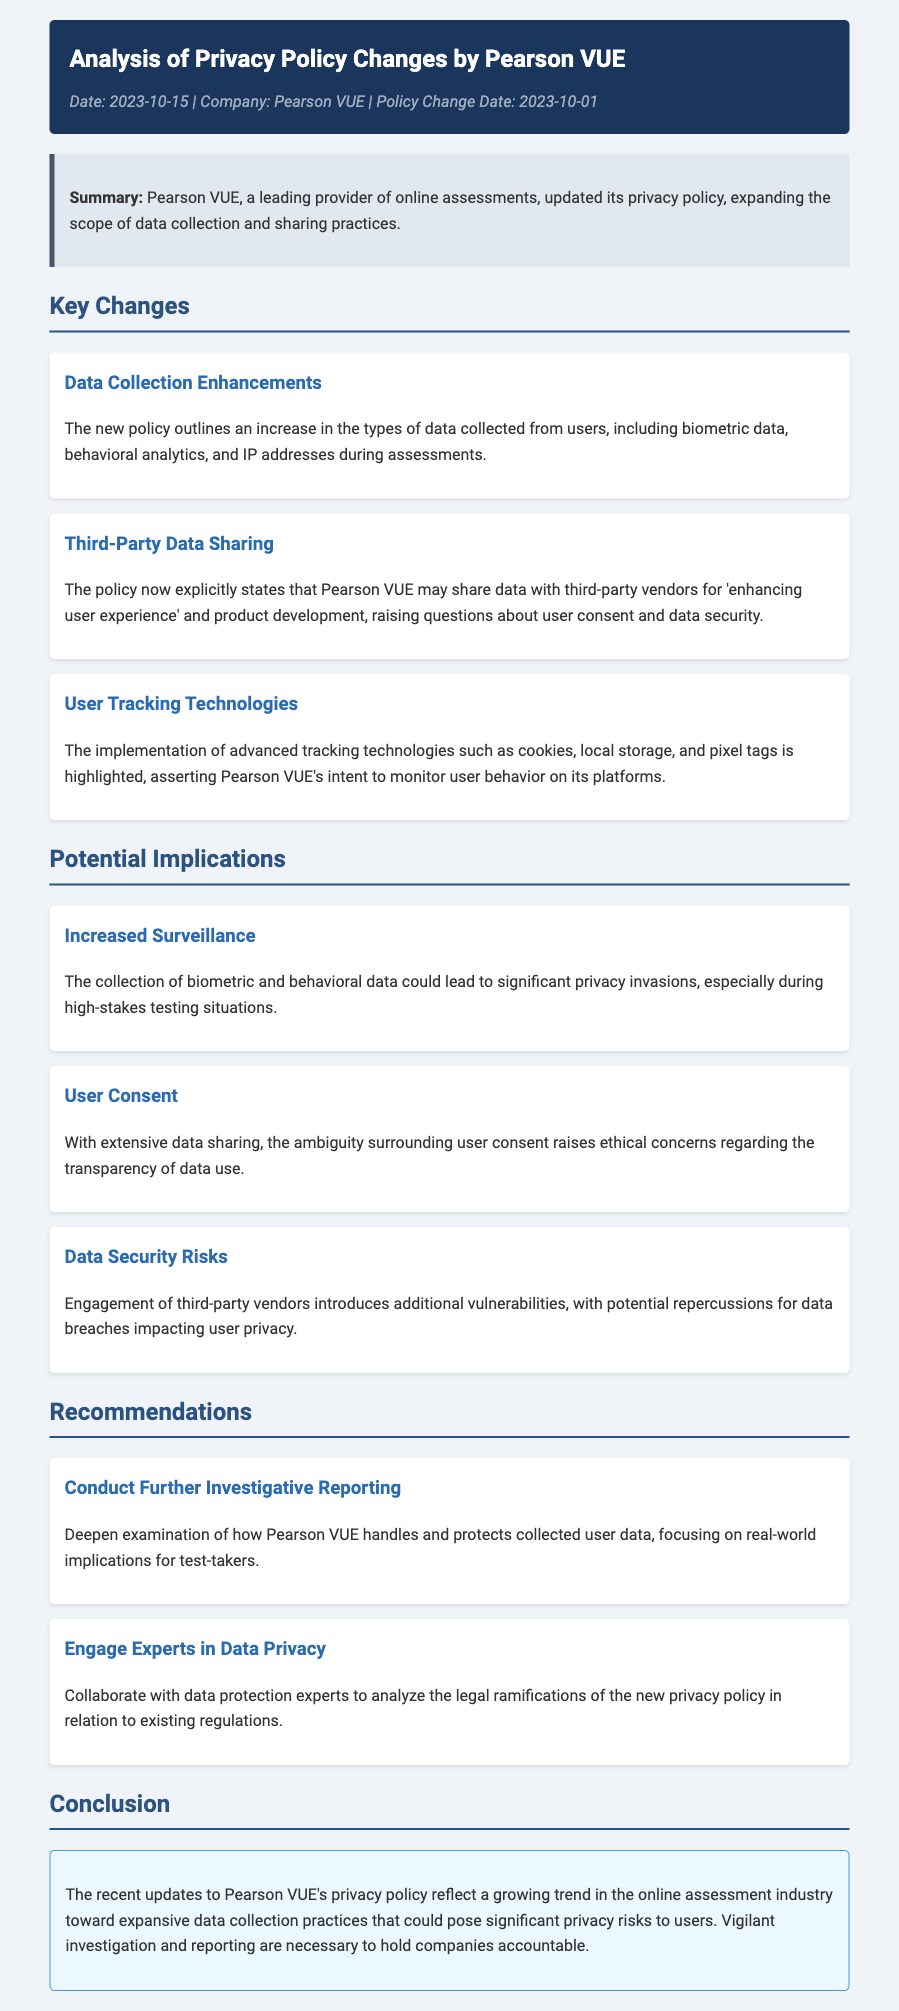What is the date of the privacy policy change? The privacy policy change took effect on 2023-10-01, as stated in the document.
Answer: 2023-10-01 What type of data collection has increased according to the new policy? The new policy mentions an increase in biometric data, behavioral analytics, and IP addresses collected during assessments.
Answer: Biometric data, behavioral analytics, and IP addresses Which company is being analyzed in this document? The document provides an analysis of Pearson VUE's privacy policy changes.
Answer: Pearson VUE What major concern is raised regarding third-party data sharing? The policy raises questions about user consent and data security when sharing data with third-party vendors.
Answer: User consent and data security What does the document suggest regarding the engagement of third-party vendors? Engagement of third-party vendors introduces additional vulnerabilities leading to potential data breaches.
Answer: Additional vulnerabilities What is one recommendation made in the document? One recommendation is to conduct further investigative reporting on how Pearson VUE handles user data.
Answer: Conduct further investigative reporting What is highlighted as a potential privacy invasion during testing situations? The collection of biometric and behavioral data in high-stakes testing situations could lead to significant privacy invasions.
Answer: Significant privacy invasions What is emphasized about user tracking technologies? The document highlights the implementation of advanced tracking technologies, including cookies, local storage, and pixel tags.
Answer: Advanced tracking technologies What trend does the conclusion mention regarding online assessment companies? The conclusion states that there is a growing trend toward expansive data collection practices in the online assessment industry.
Answer: Expansive data collection practices 